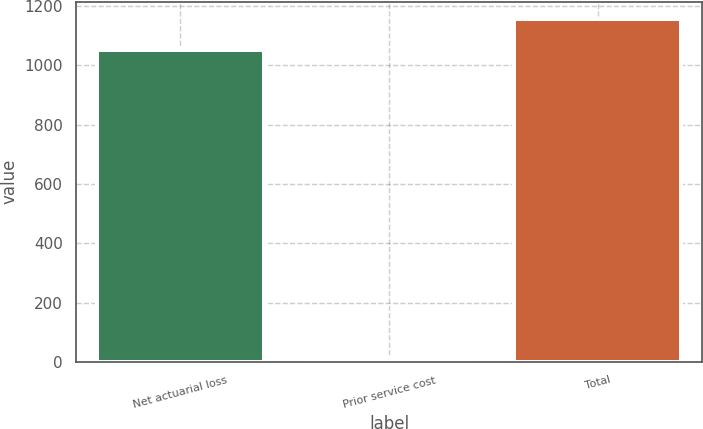Convert chart to OTSL. <chart><loc_0><loc_0><loc_500><loc_500><bar_chart><fcel>Net actuarial loss<fcel>Prior service cost<fcel>Total<nl><fcel>1052.2<fcel>10.1<fcel>1157.42<nl></chart> 